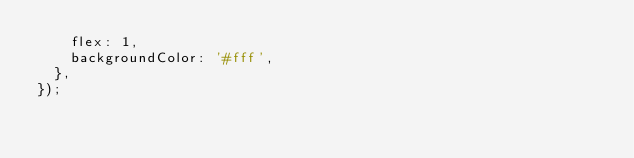<code> <loc_0><loc_0><loc_500><loc_500><_JavaScript_>    flex: 1,
    backgroundColor: '#fff',
  },
});
</code> 